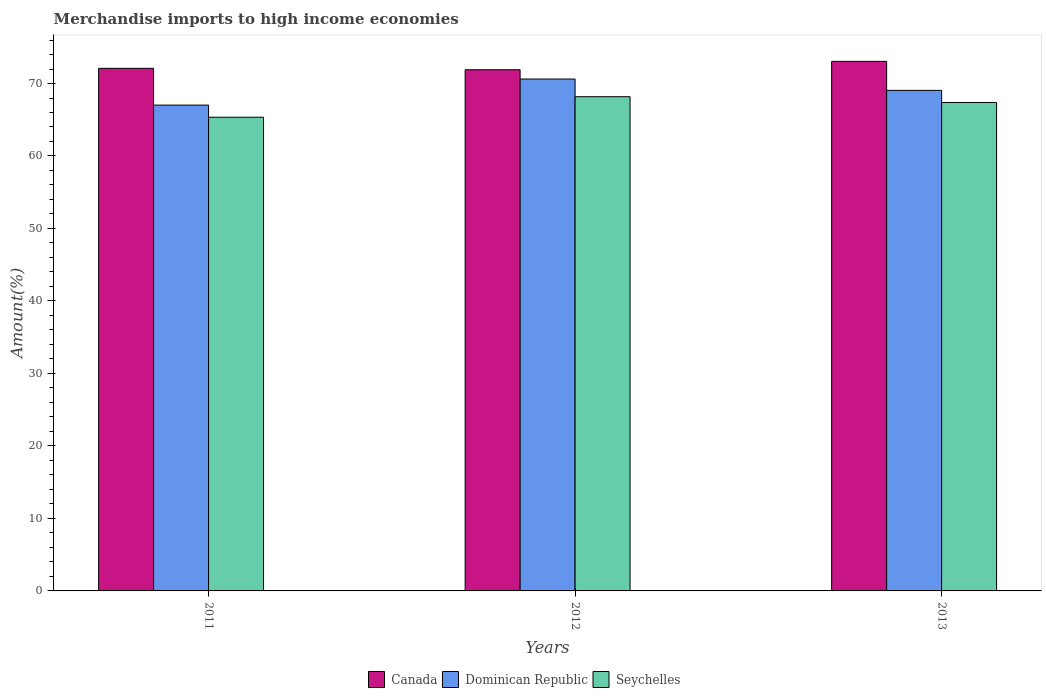How many different coloured bars are there?
Provide a succinct answer. 3. Are the number of bars per tick equal to the number of legend labels?
Keep it short and to the point. Yes. How many bars are there on the 2nd tick from the left?
Your response must be concise. 3. How many bars are there on the 1st tick from the right?
Offer a terse response. 3. What is the label of the 1st group of bars from the left?
Your answer should be compact. 2011. What is the percentage of amount earned from merchandise imports in Seychelles in 2012?
Make the answer very short. 68.18. Across all years, what is the maximum percentage of amount earned from merchandise imports in Canada?
Ensure brevity in your answer.  73.06. Across all years, what is the minimum percentage of amount earned from merchandise imports in Dominican Republic?
Provide a short and direct response. 67.02. In which year was the percentage of amount earned from merchandise imports in Dominican Republic minimum?
Your answer should be compact. 2011. What is the total percentage of amount earned from merchandise imports in Seychelles in the graph?
Keep it short and to the point. 200.9. What is the difference between the percentage of amount earned from merchandise imports in Dominican Republic in 2011 and that in 2013?
Your answer should be very brief. -2.03. What is the difference between the percentage of amount earned from merchandise imports in Dominican Republic in 2012 and the percentage of amount earned from merchandise imports in Canada in 2013?
Offer a very short reply. -2.44. What is the average percentage of amount earned from merchandise imports in Dominican Republic per year?
Your answer should be very brief. 68.9. In the year 2012, what is the difference between the percentage of amount earned from merchandise imports in Dominican Republic and percentage of amount earned from merchandise imports in Canada?
Your answer should be compact. -1.28. In how many years, is the percentage of amount earned from merchandise imports in Seychelles greater than 14 %?
Give a very brief answer. 3. What is the ratio of the percentage of amount earned from merchandise imports in Dominican Republic in 2011 to that in 2013?
Your answer should be very brief. 0.97. Is the percentage of amount earned from merchandise imports in Canada in 2012 less than that in 2013?
Provide a succinct answer. Yes. What is the difference between the highest and the second highest percentage of amount earned from merchandise imports in Seychelles?
Your answer should be compact. 0.8. What is the difference between the highest and the lowest percentage of amount earned from merchandise imports in Canada?
Keep it short and to the point. 1.16. In how many years, is the percentage of amount earned from merchandise imports in Dominican Republic greater than the average percentage of amount earned from merchandise imports in Dominican Republic taken over all years?
Ensure brevity in your answer.  2. Is it the case that in every year, the sum of the percentage of amount earned from merchandise imports in Canada and percentage of amount earned from merchandise imports in Dominican Republic is greater than the percentage of amount earned from merchandise imports in Seychelles?
Offer a very short reply. Yes. How many bars are there?
Offer a terse response. 9. Are all the bars in the graph horizontal?
Provide a succinct answer. No. How many years are there in the graph?
Give a very brief answer. 3. How are the legend labels stacked?
Give a very brief answer. Horizontal. What is the title of the graph?
Make the answer very short. Merchandise imports to high income economies. What is the label or title of the Y-axis?
Offer a terse response. Amount(%). What is the Amount(%) of Canada in 2011?
Provide a succinct answer. 72.09. What is the Amount(%) of Dominican Republic in 2011?
Give a very brief answer. 67.02. What is the Amount(%) of Seychelles in 2011?
Offer a terse response. 65.35. What is the Amount(%) in Canada in 2012?
Provide a succinct answer. 71.9. What is the Amount(%) in Dominican Republic in 2012?
Provide a succinct answer. 70.62. What is the Amount(%) in Seychelles in 2012?
Ensure brevity in your answer.  68.18. What is the Amount(%) of Canada in 2013?
Provide a succinct answer. 73.06. What is the Amount(%) of Dominican Republic in 2013?
Provide a succinct answer. 69.05. What is the Amount(%) in Seychelles in 2013?
Provide a succinct answer. 67.38. Across all years, what is the maximum Amount(%) in Canada?
Your response must be concise. 73.06. Across all years, what is the maximum Amount(%) in Dominican Republic?
Make the answer very short. 70.62. Across all years, what is the maximum Amount(%) of Seychelles?
Offer a terse response. 68.18. Across all years, what is the minimum Amount(%) of Canada?
Provide a succinct answer. 71.9. Across all years, what is the minimum Amount(%) of Dominican Republic?
Provide a succinct answer. 67.02. Across all years, what is the minimum Amount(%) of Seychelles?
Offer a very short reply. 65.35. What is the total Amount(%) in Canada in the graph?
Your answer should be compact. 217.05. What is the total Amount(%) of Dominican Republic in the graph?
Your answer should be compact. 206.69. What is the total Amount(%) of Seychelles in the graph?
Offer a terse response. 200.9. What is the difference between the Amount(%) in Canada in 2011 and that in 2012?
Provide a short and direct response. 0.2. What is the difference between the Amount(%) in Dominican Republic in 2011 and that in 2012?
Ensure brevity in your answer.  -3.6. What is the difference between the Amount(%) in Seychelles in 2011 and that in 2012?
Your answer should be compact. -2.83. What is the difference between the Amount(%) in Canada in 2011 and that in 2013?
Your answer should be compact. -0.96. What is the difference between the Amount(%) of Dominican Republic in 2011 and that in 2013?
Provide a succinct answer. -2.03. What is the difference between the Amount(%) of Seychelles in 2011 and that in 2013?
Provide a short and direct response. -2.03. What is the difference between the Amount(%) of Canada in 2012 and that in 2013?
Keep it short and to the point. -1.16. What is the difference between the Amount(%) of Dominican Republic in 2012 and that in 2013?
Give a very brief answer. 1.57. What is the difference between the Amount(%) of Seychelles in 2012 and that in 2013?
Provide a succinct answer. 0.8. What is the difference between the Amount(%) of Canada in 2011 and the Amount(%) of Dominican Republic in 2012?
Provide a succinct answer. 1.48. What is the difference between the Amount(%) in Canada in 2011 and the Amount(%) in Seychelles in 2012?
Provide a short and direct response. 3.92. What is the difference between the Amount(%) in Dominican Republic in 2011 and the Amount(%) in Seychelles in 2012?
Offer a terse response. -1.16. What is the difference between the Amount(%) in Canada in 2011 and the Amount(%) in Dominican Republic in 2013?
Keep it short and to the point. 3.04. What is the difference between the Amount(%) in Canada in 2011 and the Amount(%) in Seychelles in 2013?
Keep it short and to the point. 4.72. What is the difference between the Amount(%) of Dominican Republic in 2011 and the Amount(%) of Seychelles in 2013?
Ensure brevity in your answer.  -0.36. What is the difference between the Amount(%) in Canada in 2012 and the Amount(%) in Dominican Republic in 2013?
Keep it short and to the point. 2.84. What is the difference between the Amount(%) in Canada in 2012 and the Amount(%) in Seychelles in 2013?
Provide a succinct answer. 4.52. What is the difference between the Amount(%) of Dominican Republic in 2012 and the Amount(%) of Seychelles in 2013?
Your answer should be compact. 3.24. What is the average Amount(%) in Canada per year?
Keep it short and to the point. 72.35. What is the average Amount(%) in Dominican Republic per year?
Ensure brevity in your answer.  68.9. What is the average Amount(%) in Seychelles per year?
Ensure brevity in your answer.  66.97. In the year 2011, what is the difference between the Amount(%) of Canada and Amount(%) of Dominican Republic?
Offer a very short reply. 5.07. In the year 2011, what is the difference between the Amount(%) of Canada and Amount(%) of Seychelles?
Make the answer very short. 6.75. In the year 2011, what is the difference between the Amount(%) in Dominican Republic and Amount(%) in Seychelles?
Your answer should be very brief. 1.67. In the year 2012, what is the difference between the Amount(%) of Canada and Amount(%) of Dominican Republic?
Provide a short and direct response. 1.28. In the year 2012, what is the difference between the Amount(%) in Canada and Amount(%) in Seychelles?
Offer a terse response. 3.72. In the year 2012, what is the difference between the Amount(%) of Dominican Republic and Amount(%) of Seychelles?
Offer a very short reply. 2.44. In the year 2013, what is the difference between the Amount(%) of Canada and Amount(%) of Dominican Republic?
Your answer should be compact. 4. In the year 2013, what is the difference between the Amount(%) of Canada and Amount(%) of Seychelles?
Give a very brief answer. 5.68. In the year 2013, what is the difference between the Amount(%) of Dominican Republic and Amount(%) of Seychelles?
Ensure brevity in your answer.  1.68. What is the ratio of the Amount(%) of Canada in 2011 to that in 2012?
Your answer should be very brief. 1. What is the ratio of the Amount(%) of Dominican Republic in 2011 to that in 2012?
Make the answer very short. 0.95. What is the ratio of the Amount(%) in Seychelles in 2011 to that in 2012?
Your answer should be very brief. 0.96. What is the ratio of the Amount(%) of Canada in 2011 to that in 2013?
Your answer should be compact. 0.99. What is the ratio of the Amount(%) of Dominican Republic in 2011 to that in 2013?
Keep it short and to the point. 0.97. What is the ratio of the Amount(%) in Seychelles in 2011 to that in 2013?
Offer a very short reply. 0.97. What is the ratio of the Amount(%) in Canada in 2012 to that in 2013?
Your answer should be compact. 0.98. What is the ratio of the Amount(%) of Dominican Republic in 2012 to that in 2013?
Offer a very short reply. 1.02. What is the ratio of the Amount(%) in Seychelles in 2012 to that in 2013?
Give a very brief answer. 1.01. What is the difference between the highest and the second highest Amount(%) in Canada?
Provide a succinct answer. 0.96. What is the difference between the highest and the second highest Amount(%) of Dominican Republic?
Your answer should be compact. 1.57. What is the difference between the highest and the second highest Amount(%) of Seychelles?
Give a very brief answer. 0.8. What is the difference between the highest and the lowest Amount(%) of Canada?
Make the answer very short. 1.16. What is the difference between the highest and the lowest Amount(%) in Dominican Republic?
Ensure brevity in your answer.  3.6. What is the difference between the highest and the lowest Amount(%) of Seychelles?
Your answer should be compact. 2.83. 